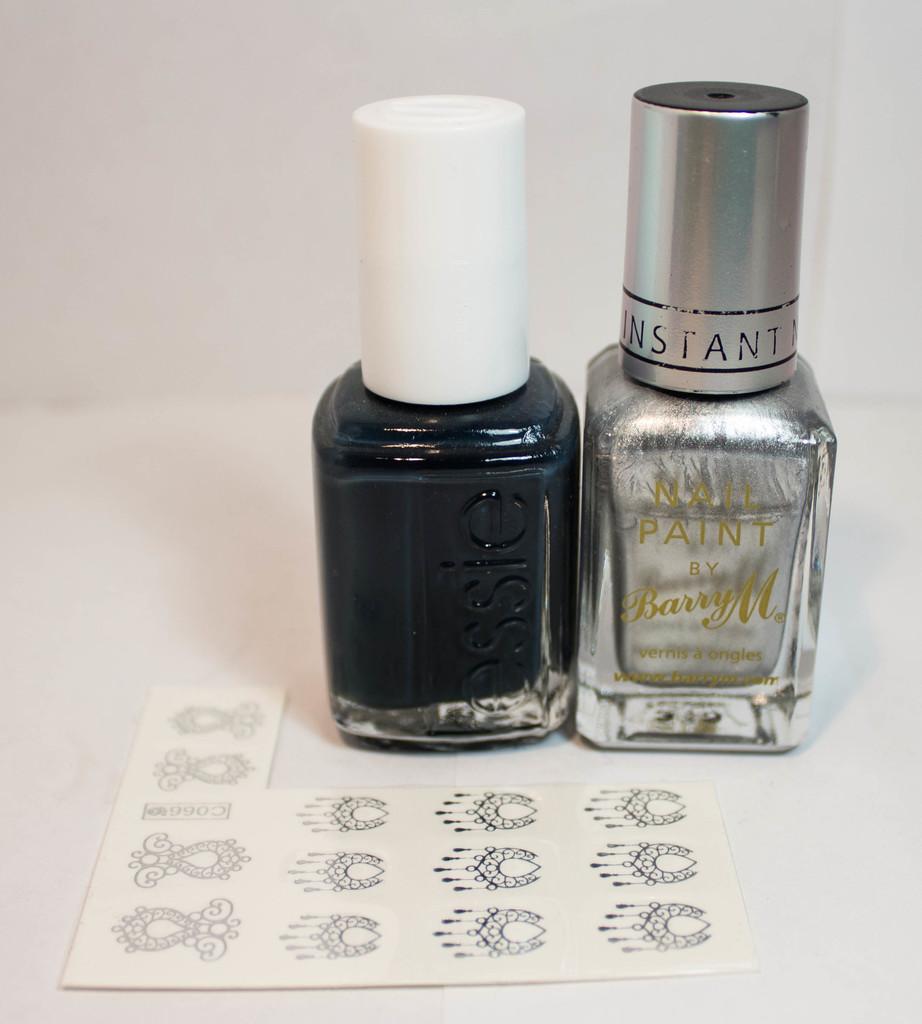What is written in gold on the nail polish to the right?
Offer a very short reply. Nail paint by barry m. 